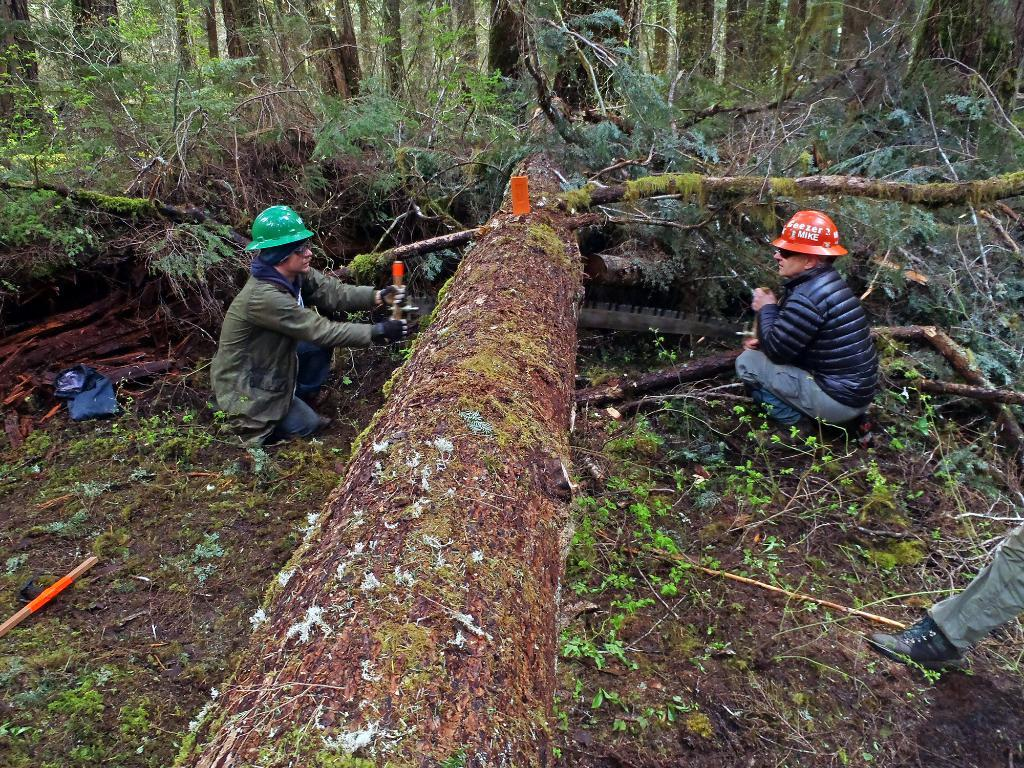How many people are in the image? There is a group of persons in the image. What are the persons doing in the image? Two persons are cutting a tree with a knife. Where are the persons standing in the image? The persons are standing on the ground. What can be seen in the background of the image? There is a background of grouped trees in the image. How many coughs can be heard from the persons in the image? There is no indication of coughing in the image; the persons are focused on cutting a tree with a knife. 